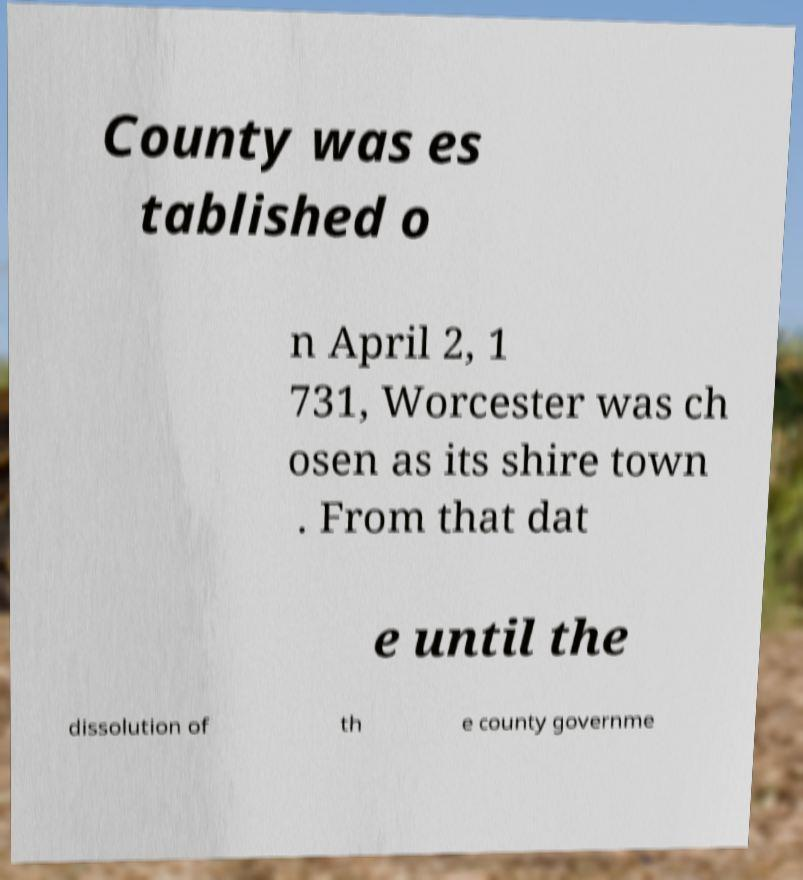Please identify and transcribe the text found in this image. County was es tablished o n April 2, 1 731, Worcester was ch osen as its shire town . From that dat e until the dissolution of th e county governme 